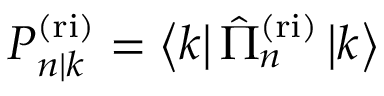<formula> <loc_0><loc_0><loc_500><loc_500>P _ { n | k } ^ { ( r i ) } = \left \langle k \right | \hat { \Pi } _ { n } ^ { ( r i ) } \left | k \right \rangle</formula> 